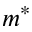Convert formula to latex. <formula><loc_0><loc_0><loc_500><loc_500>m ^ { * }</formula> 